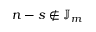<formula> <loc_0><loc_0><loc_500><loc_500>{ n - s } \notin \mathbb { J } _ { m }</formula> 